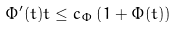Convert formula to latex. <formula><loc_0><loc_0><loc_500><loc_500>\Phi ^ { \prime } ( t ) t \leq c _ { \Phi } \left ( 1 + \Phi ( t ) \right )</formula> 